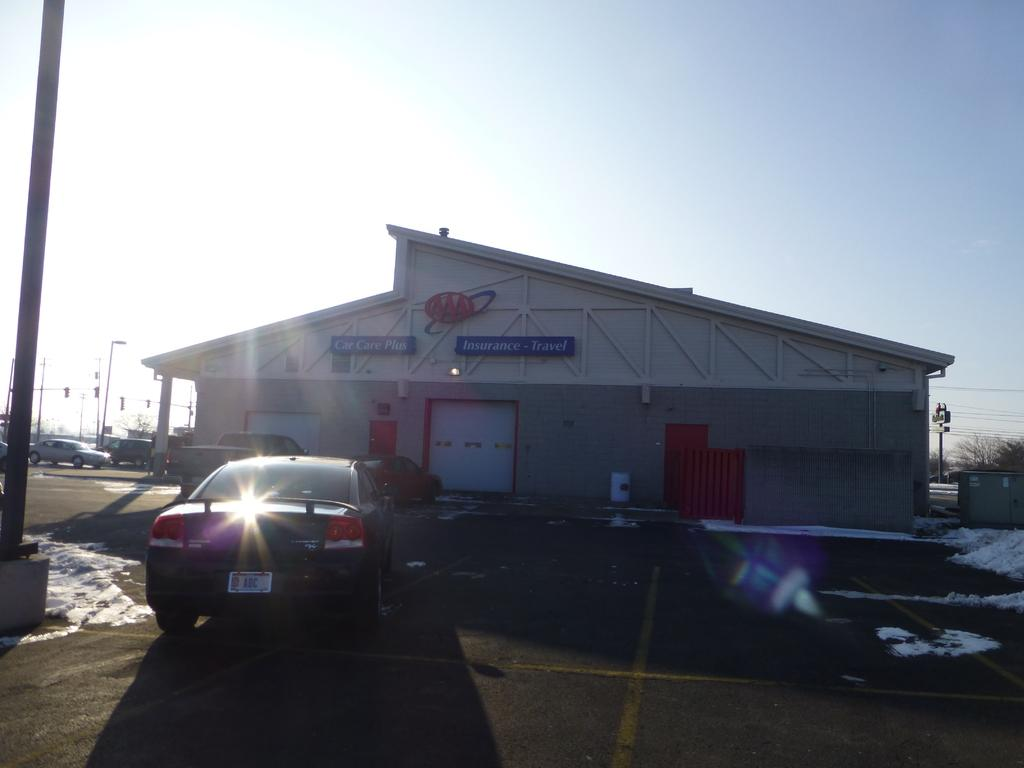What type of structure is visible in the image? There is a building in the image. What is written or displayed on the building? There is a board with text on the building. What can be seen moving in the image? There are vehicles in the image. What is the ground covered with in the image? Snow is present on the ground. What are the tall, thin objects in the image? There are poles in the image. What type of vegetation is present in the image? There are trees in the image. What is visible above the ground in the image? The sky is visible in the image. Can you see the branch of the tree moving in the image? There is no branch moving in the image; the trees are stationary. How many people are in the room in the image? There is no room present in the image, as it features an outdoor scene with a building, vehicles, snow, poles, trees, and sky. 